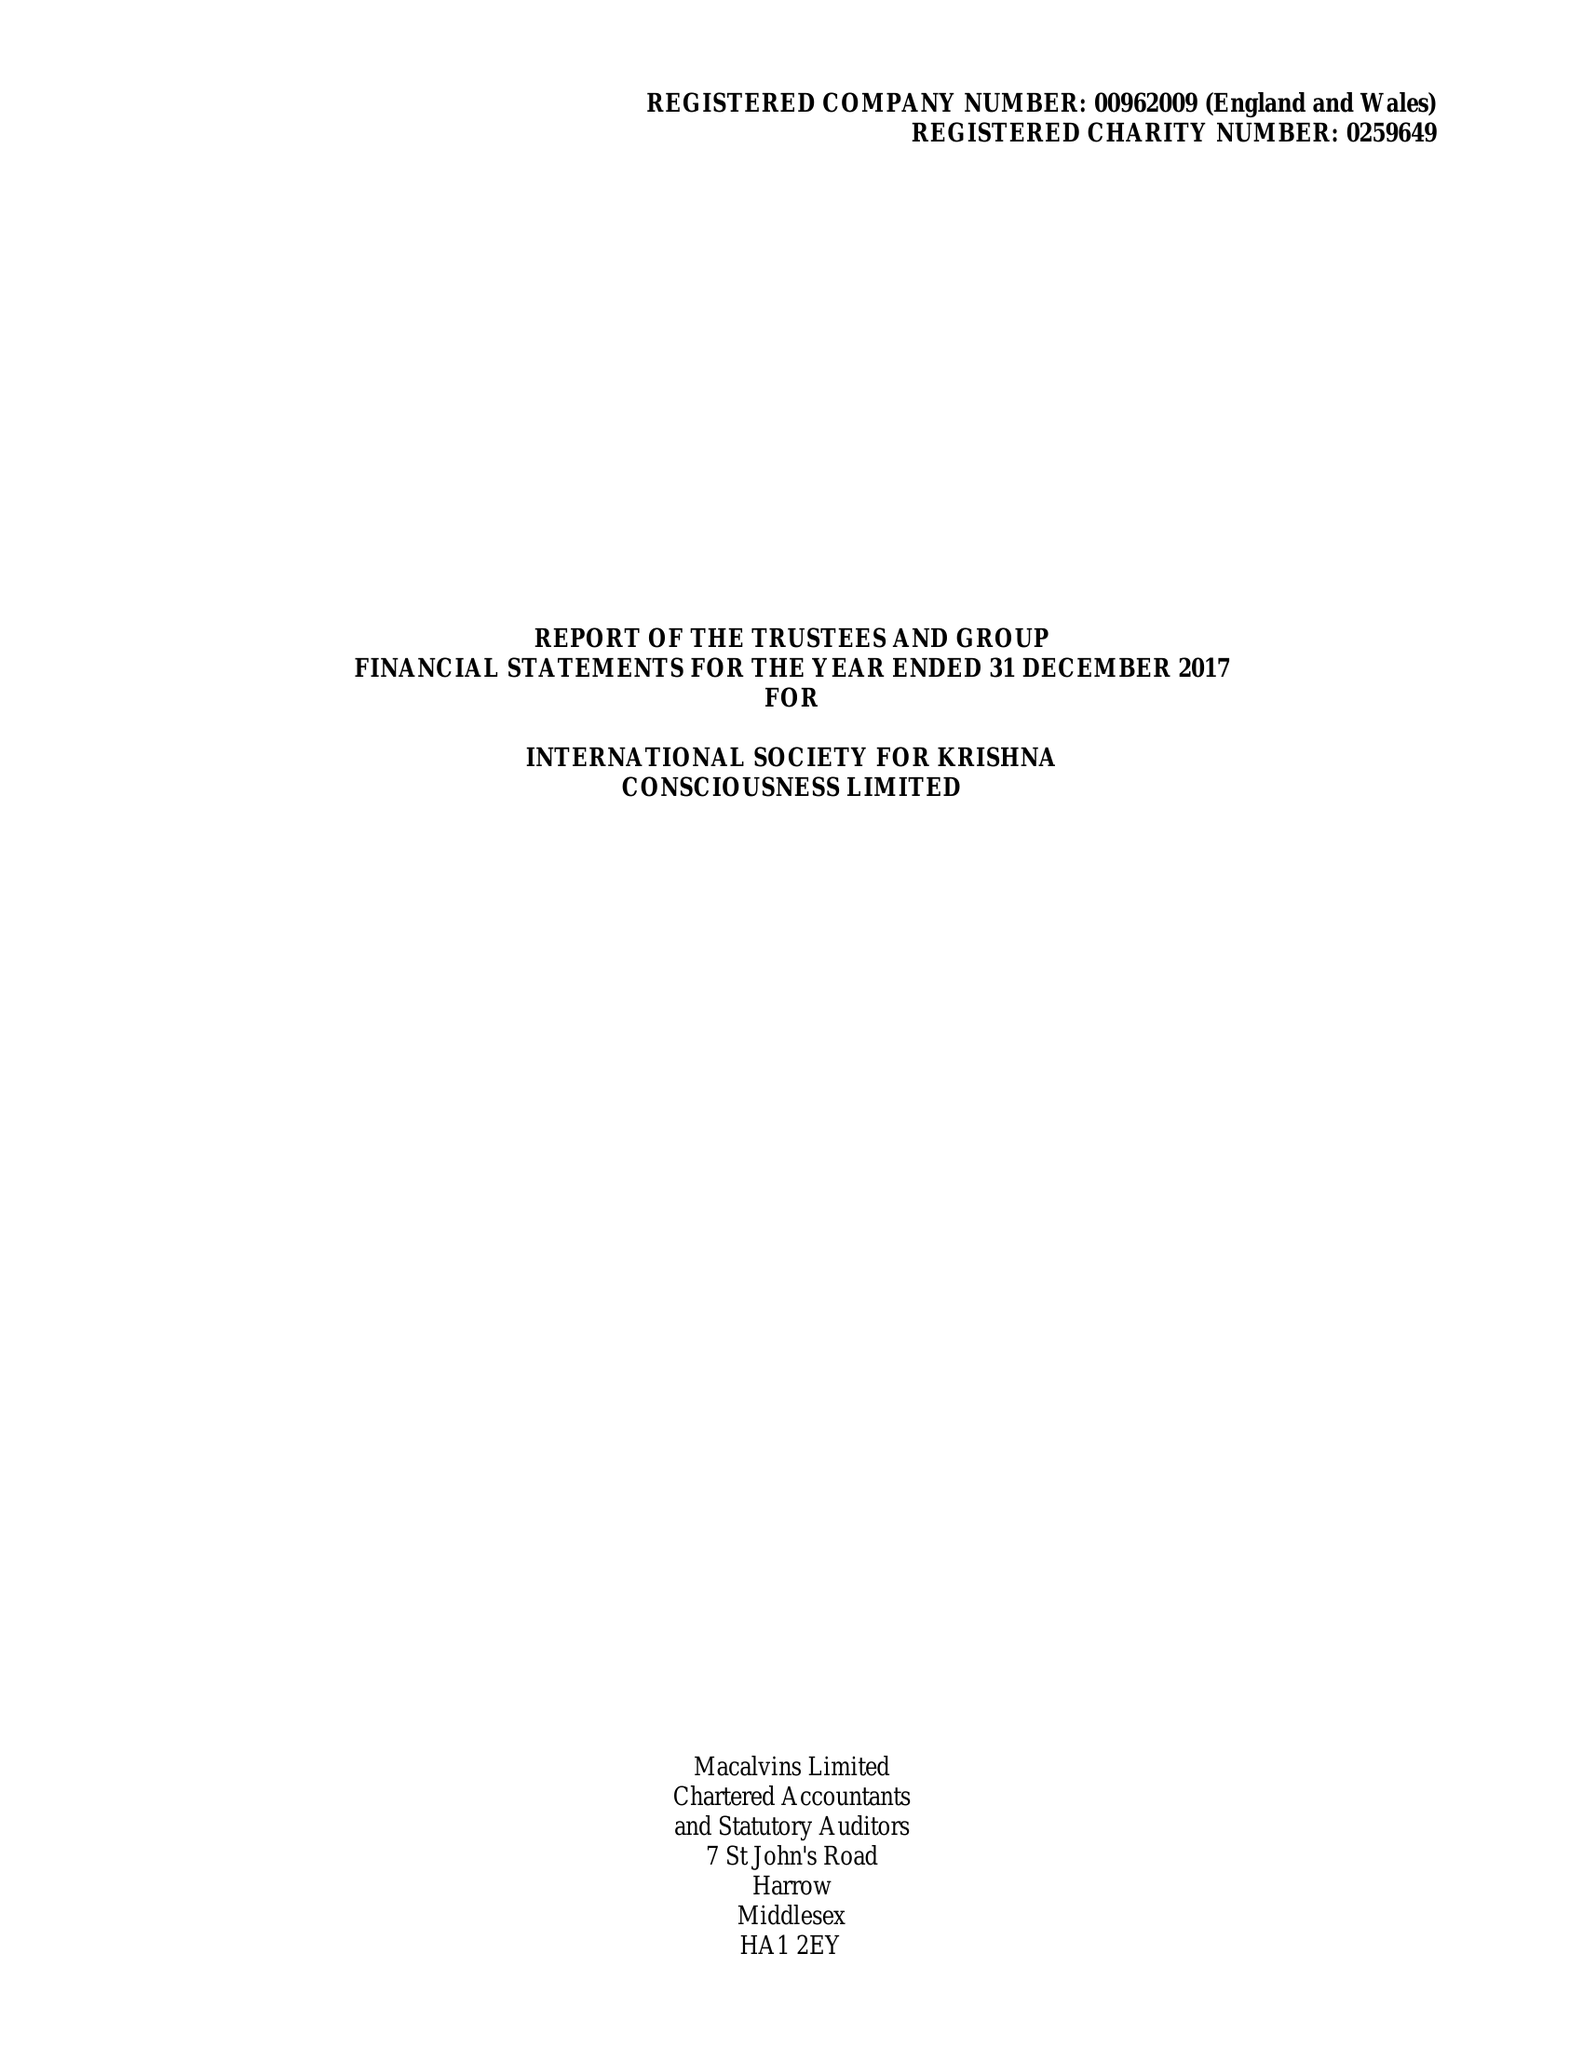What is the value for the charity_number?
Answer the question using a single word or phrase. 259649 